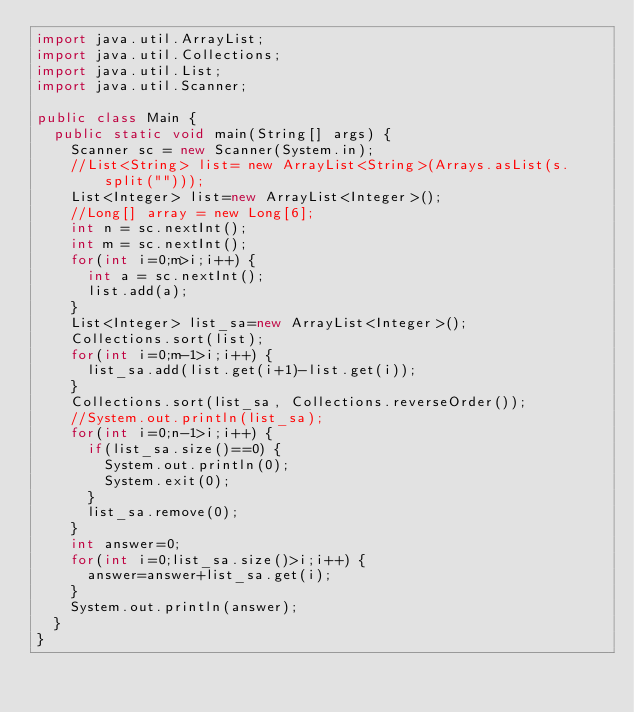Convert code to text. <code><loc_0><loc_0><loc_500><loc_500><_Java_>import java.util.ArrayList;
import java.util.Collections;
import java.util.List;
import java.util.Scanner;

public class Main {
	public static void main(String[] args) {
		Scanner sc = new Scanner(System.in);
		//List<String> list= new ArrayList<String>(Arrays.asList(s.split("")));
		List<Integer> list=new ArrayList<Integer>();
		//Long[] array = new Long[6];
		int n = sc.nextInt();
		int m = sc.nextInt();
		for(int i=0;m>i;i++) {
			int a = sc.nextInt();
			list.add(a);
		}
		List<Integer> list_sa=new ArrayList<Integer>();
		Collections.sort(list);
		for(int i=0;m-1>i;i++) {
			list_sa.add(list.get(i+1)-list.get(i));
		}
		Collections.sort(list_sa, Collections.reverseOrder());
		//System.out.println(list_sa);
		for(int i=0;n-1>i;i++) {
			if(list_sa.size()==0) {
				System.out.println(0);
				System.exit(0);
			}
			list_sa.remove(0);
		}
		int answer=0;
		for(int i=0;list_sa.size()>i;i++) {
			answer=answer+list_sa.get(i);
		}
		System.out.println(answer);
	}
}</code> 